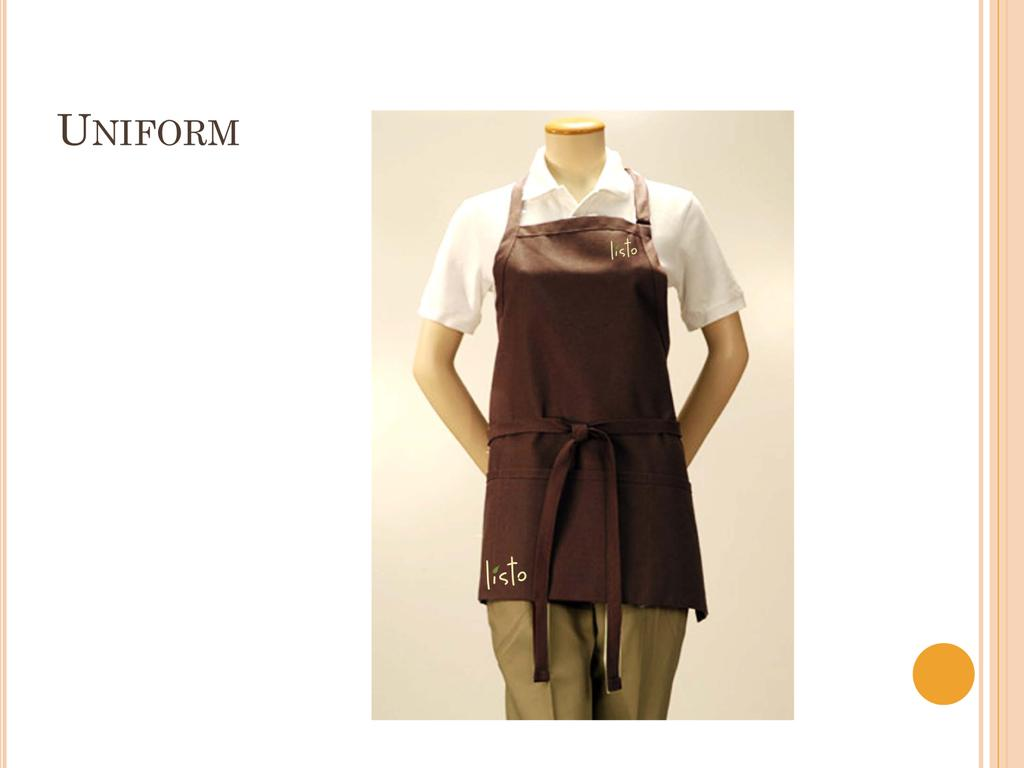What is unusual about the person depicted in the image? The person in the image does not have a head. What is the person wearing? The person is wearing a uniform. Where can you find text in the image? There is text at the top left side of the image. What type of support does the person's muscle need in the image? There is no mention of a muscle or support in the image; it features a person without a head wearing a uniform and text at the top left side. 